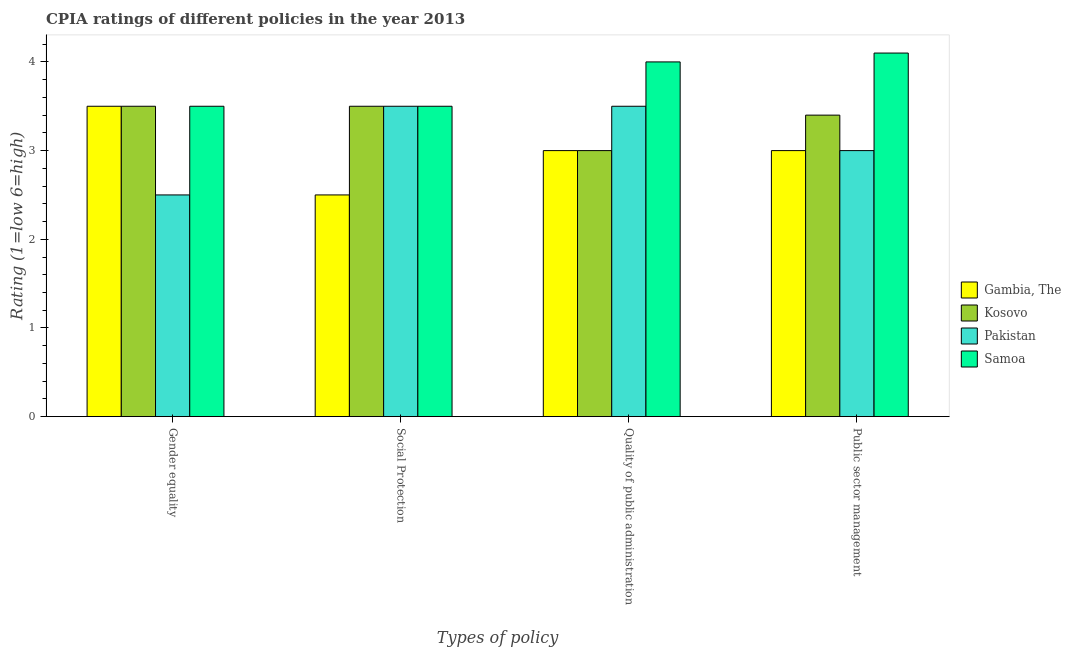How many different coloured bars are there?
Offer a terse response. 4. How many groups of bars are there?
Make the answer very short. 4. Are the number of bars on each tick of the X-axis equal?
Your response must be concise. Yes. How many bars are there on the 3rd tick from the left?
Provide a succinct answer. 4. How many bars are there on the 4th tick from the right?
Your response must be concise. 4. What is the label of the 4th group of bars from the left?
Ensure brevity in your answer.  Public sector management. In which country was the cpia rating of gender equality maximum?
Keep it short and to the point. Gambia, The. In which country was the cpia rating of quality of public administration minimum?
Your answer should be compact. Gambia, The. What is the total cpia rating of social protection in the graph?
Keep it short and to the point. 13. What is the average cpia rating of social protection per country?
Your answer should be compact. 3.25. In how many countries, is the cpia rating of gender equality greater than 2.4 ?
Your answer should be very brief. 4. What is the ratio of the cpia rating of gender equality in Samoa to that in Kosovo?
Ensure brevity in your answer.  1. Is the cpia rating of social protection in Gambia, The less than that in Kosovo?
Keep it short and to the point. Yes. What is the difference between the highest and the second highest cpia rating of quality of public administration?
Ensure brevity in your answer.  0.5. Is the sum of the cpia rating of quality of public administration in Pakistan and Gambia, The greater than the maximum cpia rating of gender equality across all countries?
Offer a very short reply. Yes. Is it the case that in every country, the sum of the cpia rating of public sector management and cpia rating of quality of public administration is greater than the sum of cpia rating of gender equality and cpia rating of social protection?
Your answer should be very brief. No. What does the 2nd bar from the left in Quality of public administration represents?
Your response must be concise. Kosovo. Is it the case that in every country, the sum of the cpia rating of gender equality and cpia rating of social protection is greater than the cpia rating of quality of public administration?
Make the answer very short. Yes. How many bars are there?
Make the answer very short. 16. Are all the bars in the graph horizontal?
Your answer should be very brief. No. How many countries are there in the graph?
Your answer should be very brief. 4. What is the difference between two consecutive major ticks on the Y-axis?
Keep it short and to the point. 1. Are the values on the major ticks of Y-axis written in scientific E-notation?
Your response must be concise. No. Does the graph contain any zero values?
Ensure brevity in your answer.  No. Does the graph contain grids?
Offer a very short reply. No. Where does the legend appear in the graph?
Your answer should be very brief. Center right. How many legend labels are there?
Your response must be concise. 4. What is the title of the graph?
Keep it short and to the point. CPIA ratings of different policies in the year 2013. What is the label or title of the X-axis?
Offer a very short reply. Types of policy. What is the Rating (1=low 6=high) of Gambia, The in Gender equality?
Make the answer very short. 3.5. What is the Rating (1=low 6=high) of Kosovo in Gender equality?
Your answer should be compact. 3.5. What is the Rating (1=low 6=high) of Samoa in Gender equality?
Offer a terse response. 3.5. What is the Rating (1=low 6=high) in Pakistan in Social Protection?
Offer a terse response. 3.5. What is the Rating (1=low 6=high) of Kosovo in Quality of public administration?
Provide a short and direct response. 3. What is the Rating (1=low 6=high) in Pakistan in Quality of public administration?
Offer a terse response. 3.5. What is the Rating (1=low 6=high) of Samoa in Quality of public administration?
Ensure brevity in your answer.  4. What is the Rating (1=low 6=high) in Kosovo in Public sector management?
Provide a short and direct response. 3.4. What is the Rating (1=low 6=high) of Pakistan in Public sector management?
Ensure brevity in your answer.  3. Across all Types of policy, what is the maximum Rating (1=low 6=high) in Gambia, The?
Your answer should be very brief. 3.5. Across all Types of policy, what is the maximum Rating (1=low 6=high) in Samoa?
Your answer should be very brief. 4.1. Across all Types of policy, what is the minimum Rating (1=low 6=high) in Kosovo?
Give a very brief answer. 3. Across all Types of policy, what is the minimum Rating (1=low 6=high) of Samoa?
Provide a short and direct response. 3.5. What is the total Rating (1=low 6=high) of Gambia, The in the graph?
Keep it short and to the point. 12. What is the total Rating (1=low 6=high) in Pakistan in the graph?
Offer a very short reply. 12.5. What is the total Rating (1=low 6=high) of Samoa in the graph?
Provide a succinct answer. 15.1. What is the difference between the Rating (1=low 6=high) in Kosovo in Gender equality and that in Social Protection?
Your answer should be very brief. 0. What is the difference between the Rating (1=low 6=high) of Pakistan in Gender equality and that in Social Protection?
Offer a very short reply. -1. What is the difference between the Rating (1=low 6=high) in Samoa in Gender equality and that in Social Protection?
Offer a very short reply. 0. What is the difference between the Rating (1=low 6=high) of Gambia, The in Gender equality and that in Quality of public administration?
Provide a succinct answer. 0.5. What is the difference between the Rating (1=low 6=high) of Samoa in Gender equality and that in Quality of public administration?
Your response must be concise. -0.5. What is the difference between the Rating (1=low 6=high) in Gambia, The in Gender equality and that in Public sector management?
Ensure brevity in your answer.  0.5. What is the difference between the Rating (1=low 6=high) in Pakistan in Gender equality and that in Public sector management?
Offer a very short reply. -0.5. What is the difference between the Rating (1=low 6=high) in Kosovo in Social Protection and that in Quality of public administration?
Make the answer very short. 0.5. What is the difference between the Rating (1=low 6=high) of Pakistan in Social Protection and that in Quality of public administration?
Keep it short and to the point. 0. What is the difference between the Rating (1=low 6=high) of Gambia, The in Quality of public administration and that in Public sector management?
Your answer should be compact. 0. What is the difference between the Rating (1=low 6=high) of Kosovo in Quality of public administration and that in Public sector management?
Ensure brevity in your answer.  -0.4. What is the difference between the Rating (1=low 6=high) in Samoa in Quality of public administration and that in Public sector management?
Offer a very short reply. -0.1. What is the difference between the Rating (1=low 6=high) of Gambia, The in Gender equality and the Rating (1=low 6=high) of Pakistan in Social Protection?
Your response must be concise. 0. What is the difference between the Rating (1=low 6=high) in Gambia, The in Gender equality and the Rating (1=low 6=high) in Samoa in Social Protection?
Your answer should be compact. 0. What is the difference between the Rating (1=low 6=high) in Kosovo in Gender equality and the Rating (1=low 6=high) in Pakistan in Social Protection?
Your response must be concise. 0. What is the difference between the Rating (1=low 6=high) of Kosovo in Gender equality and the Rating (1=low 6=high) of Samoa in Social Protection?
Provide a succinct answer. 0. What is the difference between the Rating (1=low 6=high) of Pakistan in Gender equality and the Rating (1=low 6=high) of Samoa in Social Protection?
Make the answer very short. -1. What is the difference between the Rating (1=low 6=high) in Kosovo in Gender equality and the Rating (1=low 6=high) in Samoa in Quality of public administration?
Provide a short and direct response. -0.5. What is the difference between the Rating (1=low 6=high) of Gambia, The in Gender equality and the Rating (1=low 6=high) of Kosovo in Public sector management?
Provide a short and direct response. 0.1. What is the difference between the Rating (1=low 6=high) in Gambia, The in Gender equality and the Rating (1=low 6=high) in Pakistan in Public sector management?
Offer a terse response. 0.5. What is the difference between the Rating (1=low 6=high) of Gambia, The in Gender equality and the Rating (1=low 6=high) of Samoa in Public sector management?
Provide a succinct answer. -0.6. What is the difference between the Rating (1=low 6=high) in Kosovo in Gender equality and the Rating (1=low 6=high) in Pakistan in Public sector management?
Keep it short and to the point. 0.5. What is the difference between the Rating (1=low 6=high) of Kosovo in Gender equality and the Rating (1=low 6=high) of Samoa in Public sector management?
Your response must be concise. -0.6. What is the difference between the Rating (1=low 6=high) of Gambia, The in Social Protection and the Rating (1=low 6=high) of Pakistan in Quality of public administration?
Offer a terse response. -1. What is the difference between the Rating (1=low 6=high) of Gambia, The in Social Protection and the Rating (1=low 6=high) of Pakistan in Public sector management?
Offer a terse response. -0.5. What is the difference between the Rating (1=low 6=high) in Gambia, The in Social Protection and the Rating (1=low 6=high) in Samoa in Public sector management?
Ensure brevity in your answer.  -1.6. What is the difference between the Rating (1=low 6=high) in Kosovo in Social Protection and the Rating (1=low 6=high) in Pakistan in Public sector management?
Keep it short and to the point. 0.5. What is the difference between the Rating (1=low 6=high) of Kosovo in Social Protection and the Rating (1=low 6=high) of Samoa in Public sector management?
Give a very brief answer. -0.6. What is the difference between the Rating (1=low 6=high) of Gambia, The in Quality of public administration and the Rating (1=low 6=high) of Pakistan in Public sector management?
Provide a succinct answer. 0. What is the difference between the Rating (1=low 6=high) in Kosovo in Quality of public administration and the Rating (1=low 6=high) in Samoa in Public sector management?
Your answer should be very brief. -1.1. What is the average Rating (1=low 6=high) in Gambia, The per Types of policy?
Your answer should be very brief. 3. What is the average Rating (1=low 6=high) of Kosovo per Types of policy?
Keep it short and to the point. 3.35. What is the average Rating (1=low 6=high) of Pakistan per Types of policy?
Give a very brief answer. 3.12. What is the average Rating (1=low 6=high) of Samoa per Types of policy?
Offer a terse response. 3.77. What is the difference between the Rating (1=low 6=high) in Gambia, The and Rating (1=low 6=high) in Kosovo in Gender equality?
Offer a terse response. 0. What is the difference between the Rating (1=low 6=high) of Gambia, The and Rating (1=low 6=high) of Pakistan in Gender equality?
Ensure brevity in your answer.  1. What is the difference between the Rating (1=low 6=high) in Kosovo and Rating (1=low 6=high) in Pakistan in Gender equality?
Keep it short and to the point. 1. What is the difference between the Rating (1=low 6=high) of Kosovo and Rating (1=low 6=high) of Samoa in Gender equality?
Make the answer very short. 0. What is the difference between the Rating (1=low 6=high) in Gambia, The and Rating (1=low 6=high) in Kosovo in Social Protection?
Offer a terse response. -1. What is the difference between the Rating (1=low 6=high) of Gambia, The and Rating (1=low 6=high) of Pakistan in Social Protection?
Ensure brevity in your answer.  -1. What is the difference between the Rating (1=low 6=high) in Kosovo and Rating (1=low 6=high) in Pakistan in Social Protection?
Your answer should be compact. 0. What is the difference between the Rating (1=low 6=high) in Kosovo and Rating (1=low 6=high) in Samoa in Social Protection?
Offer a very short reply. 0. What is the difference between the Rating (1=low 6=high) of Pakistan and Rating (1=low 6=high) of Samoa in Social Protection?
Provide a succinct answer. 0. What is the difference between the Rating (1=low 6=high) of Gambia, The and Rating (1=low 6=high) of Pakistan in Quality of public administration?
Your answer should be compact. -0.5. What is the difference between the Rating (1=low 6=high) in Kosovo and Rating (1=low 6=high) in Pakistan in Quality of public administration?
Ensure brevity in your answer.  -0.5. What is the difference between the Rating (1=low 6=high) of Kosovo and Rating (1=low 6=high) of Samoa in Quality of public administration?
Your answer should be compact. -1. What is the difference between the Rating (1=low 6=high) in Pakistan and Rating (1=low 6=high) in Samoa in Quality of public administration?
Your response must be concise. -0.5. What is the difference between the Rating (1=low 6=high) of Gambia, The and Rating (1=low 6=high) of Samoa in Public sector management?
Make the answer very short. -1.1. What is the difference between the Rating (1=low 6=high) in Kosovo and Rating (1=low 6=high) in Pakistan in Public sector management?
Keep it short and to the point. 0.4. What is the ratio of the Rating (1=low 6=high) in Kosovo in Gender equality to that in Social Protection?
Ensure brevity in your answer.  1. What is the ratio of the Rating (1=low 6=high) in Samoa in Gender equality to that in Social Protection?
Provide a succinct answer. 1. What is the ratio of the Rating (1=low 6=high) of Gambia, The in Gender equality to that in Quality of public administration?
Make the answer very short. 1.17. What is the ratio of the Rating (1=low 6=high) of Kosovo in Gender equality to that in Quality of public administration?
Your response must be concise. 1.17. What is the ratio of the Rating (1=low 6=high) of Gambia, The in Gender equality to that in Public sector management?
Your response must be concise. 1.17. What is the ratio of the Rating (1=low 6=high) of Kosovo in Gender equality to that in Public sector management?
Offer a terse response. 1.03. What is the ratio of the Rating (1=low 6=high) in Pakistan in Gender equality to that in Public sector management?
Offer a very short reply. 0.83. What is the ratio of the Rating (1=low 6=high) in Samoa in Gender equality to that in Public sector management?
Ensure brevity in your answer.  0.85. What is the ratio of the Rating (1=low 6=high) of Gambia, The in Social Protection to that in Quality of public administration?
Offer a terse response. 0.83. What is the ratio of the Rating (1=low 6=high) of Samoa in Social Protection to that in Quality of public administration?
Your answer should be compact. 0.88. What is the ratio of the Rating (1=low 6=high) in Kosovo in Social Protection to that in Public sector management?
Offer a very short reply. 1.03. What is the ratio of the Rating (1=low 6=high) in Samoa in Social Protection to that in Public sector management?
Your answer should be very brief. 0.85. What is the ratio of the Rating (1=low 6=high) of Kosovo in Quality of public administration to that in Public sector management?
Ensure brevity in your answer.  0.88. What is the ratio of the Rating (1=low 6=high) in Samoa in Quality of public administration to that in Public sector management?
Offer a very short reply. 0.98. What is the difference between the highest and the second highest Rating (1=low 6=high) in Kosovo?
Your answer should be very brief. 0. What is the difference between the highest and the second highest Rating (1=low 6=high) in Pakistan?
Make the answer very short. 0. What is the difference between the highest and the lowest Rating (1=low 6=high) of Kosovo?
Keep it short and to the point. 0.5. What is the difference between the highest and the lowest Rating (1=low 6=high) in Samoa?
Give a very brief answer. 0.6. 